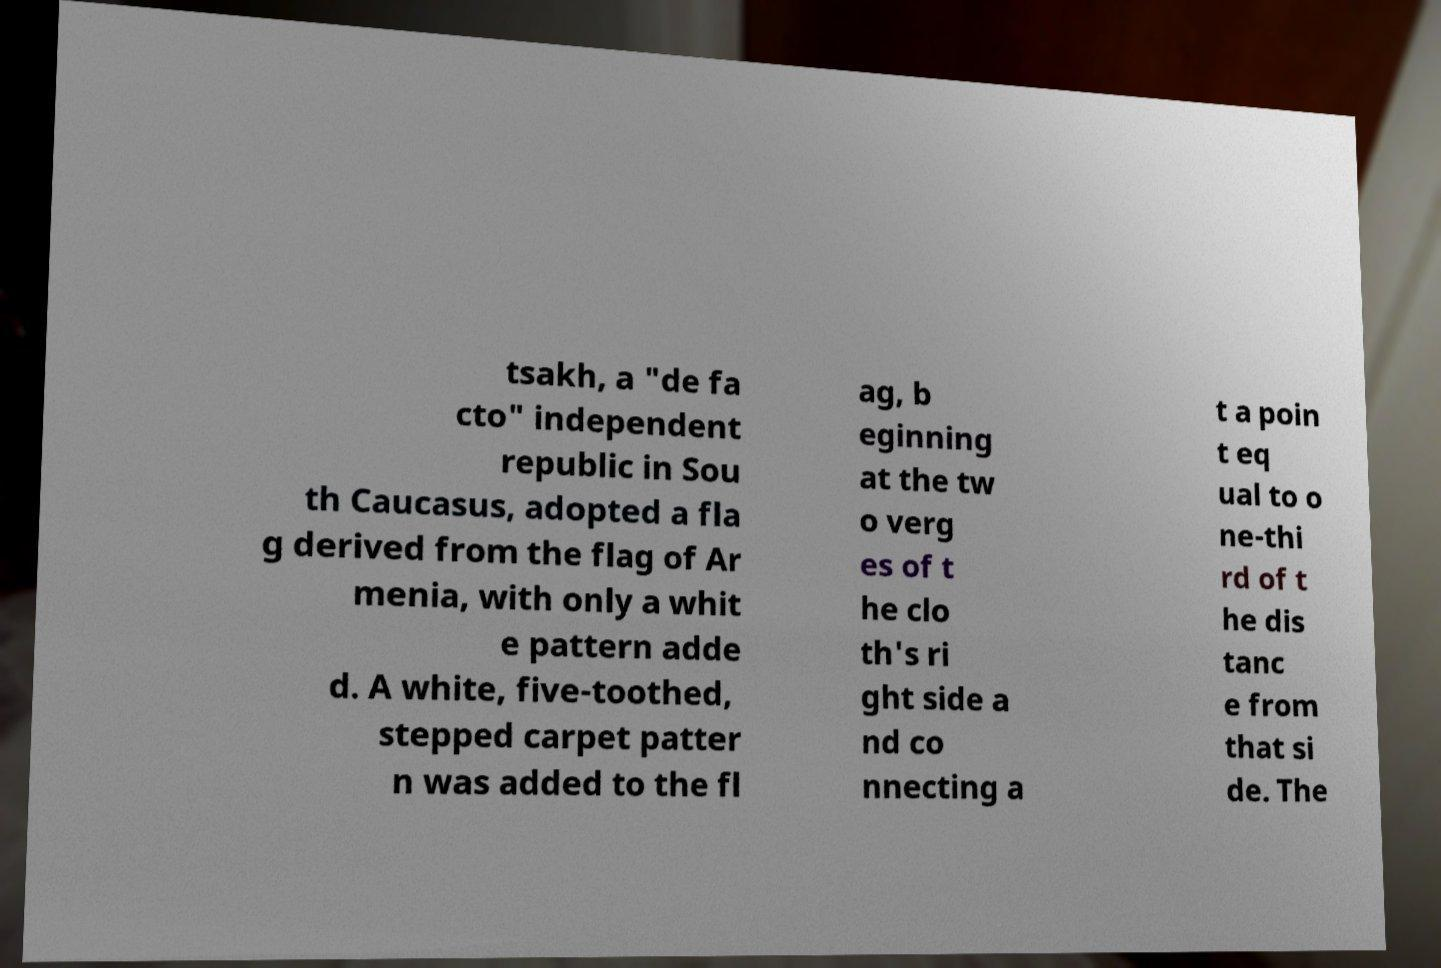I need the written content from this picture converted into text. Can you do that? tsakh, a "de fa cto" independent republic in Sou th Caucasus, adopted a fla g derived from the flag of Ar menia, with only a whit e pattern adde d. A white, five-toothed, stepped carpet patter n was added to the fl ag, b eginning at the tw o verg es of t he clo th's ri ght side a nd co nnecting a t a poin t eq ual to o ne-thi rd of t he dis tanc e from that si de. The 